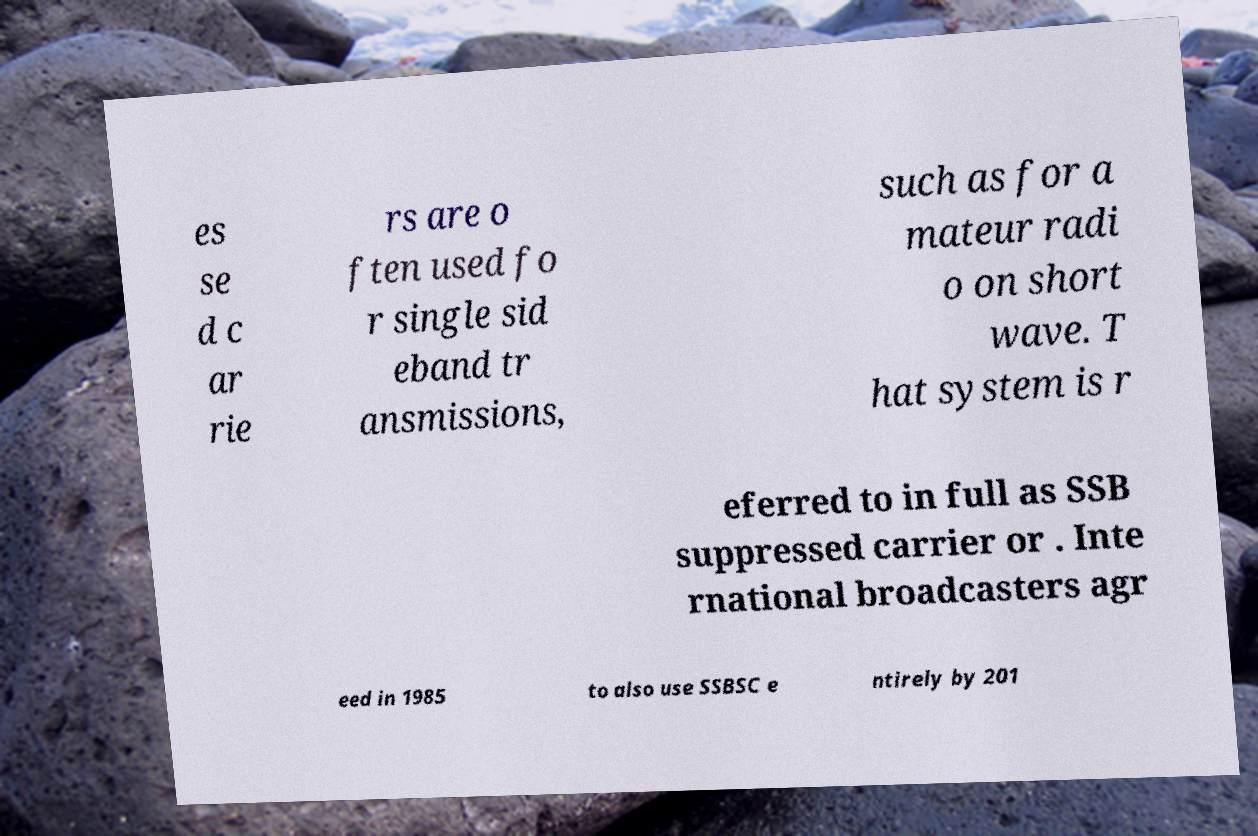Please identify and transcribe the text found in this image. es se d c ar rie rs are o ften used fo r single sid eband tr ansmissions, such as for a mateur radi o on short wave. T hat system is r eferred to in full as SSB suppressed carrier or . Inte rnational broadcasters agr eed in 1985 to also use SSBSC e ntirely by 201 